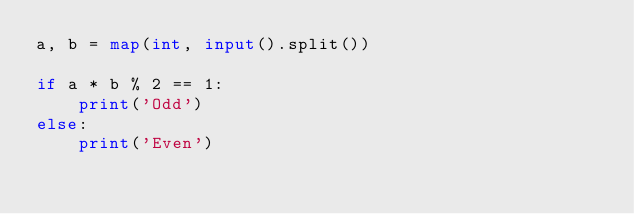<code> <loc_0><loc_0><loc_500><loc_500><_Python_>a, b = map(int, input().split())

if a * b % 2 == 1:
    print('Odd')
else:
    print('Even')</code> 